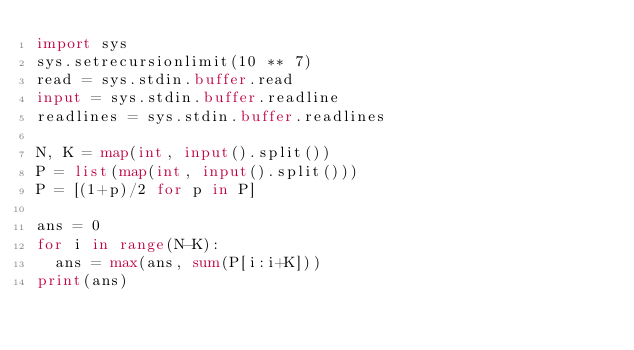<code> <loc_0><loc_0><loc_500><loc_500><_Python_>import sys
sys.setrecursionlimit(10 ** 7)
read = sys.stdin.buffer.read 
input = sys.stdin.buffer.readline
readlines = sys.stdin.buffer.readlines  

N, K = map(int, input().split())
P = list(map(int, input().split()))
P = [(1+p)/2 for p in P]

ans = 0
for i in range(N-K):
  ans = max(ans, sum(P[i:i+K]))
print(ans)  </code> 